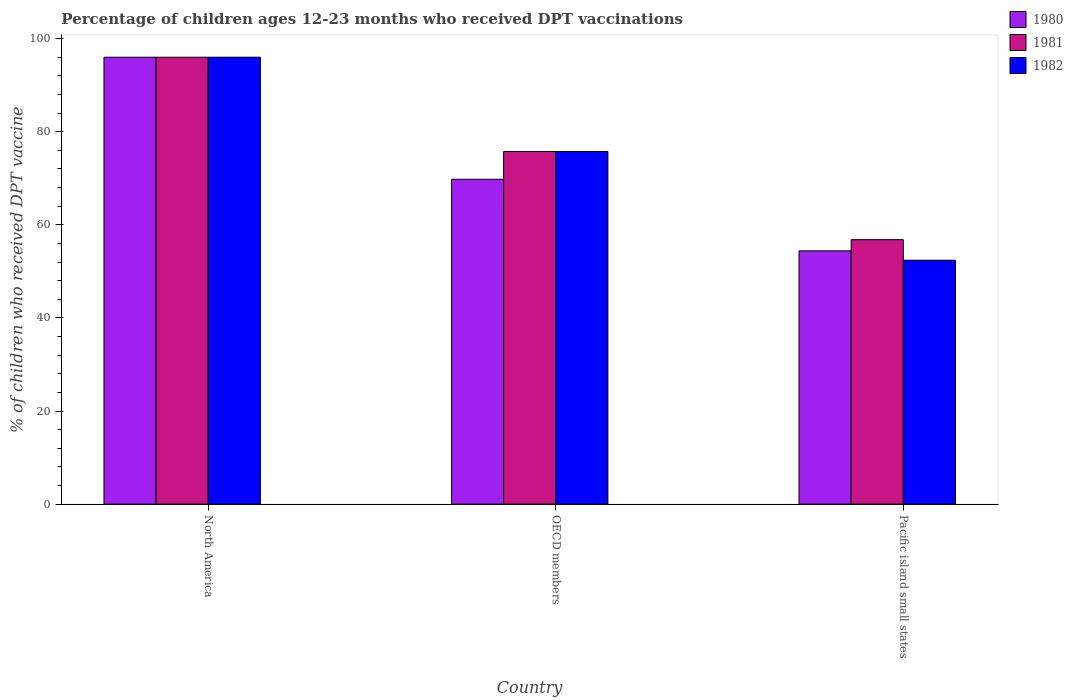How many groups of bars are there?
Offer a terse response. 3. Are the number of bars per tick equal to the number of legend labels?
Offer a very short reply. Yes. How many bars are there on the 1st tick from the left?
Provide a succinct answer. 3. How many bars are there on the 2nd tick from the right?
Ensure brevity in your answer.  3. What is the label of the 2nd group of bars from the left?
Give a very brief answer. OECD members. What is the percentage of children who received DPT vaccination in 1980 in OECD members?
Your response must be concise. 69.79. Across all countries, what is the maximum percentage of children who received DPT vaccination in 1980?
Your answer should be compact. 96. Across all countries, what is the minimum percentage of children who received DPT vaccination in 1980?
Keep it short and to the point. 54.41. In which country was the percentage of children who received DPT vaccination in 1982 minimum?
Your answer should be very brief. Pacific island small states. What is the total percentage of children who received DPT vaccination in 1981 in the graph?
Offer a terse response. 228.56. What is the difference between the percentage of children who received DPT vaccination in 1981 in North America and that in OECD members?
Your response must be concise. 20.25. What is the difference between the percentage of children who received DPT vaccination in 1981 in North America and the percentage of children who received DPT vaccination in 1982 in OECD members?
Provide a short and direct response. 20.25. What is the average percentage of children who received DPT vaccination in 1981 per country?
Give a very brief answer. 76.19. What is the difference between the percentage of children who received DPT vaccination of/in 1980 and percentage of children who received DPT vaccination of/in 1982 in Pacific island small states?
Offer a terse response. 2.01. In how many countries, is the percentage of children who received DPT vaccination in 1982 greater than 72 %?
Offer a terse response. 2. What is the ratio of the percentage of children who received DPT vaccination in 1982 in OECD members to that in Pacific island small states?
Ensure brevity in your answer.  1.45. What is the difference between the highest and the second highest percentage of children who received DPT vaccination in 1980?
Your answer should be very brief. 26.21. What is the difference between the highest and the lowest percentage of children who received DPT vaccination in 1982?
Your answer should be very brief. 43.6. What does the 1st bar from the right in Pacific island small states represents?
Your response must be concise. 1982. Are all the bars in the graph horizontal?
Make the answer very short. No. How many countries are there in the graph?
Provide a short and direct response. 3. What is the difference between two consecutive major ticks on the Y-axis?
Offer a terse response. 20. Are the values on the major ticks of Y-axis written in scientific E-notation?
Offer a terse response. No. Does the graph contain any zero values?
Provide a succinct answer. No. How many legend labels are there?
Provide a succinct answer. 3. How are the legend labels stacked?
Give a very brief answer. Vertical. What is the title of the graph?
Make the answer very short. Percentage of children ages 12-23 months who received DPT vaccinations. What is the label or title of the Y-axis?
Offer a very short reply. % of children who received DPT vaccine. What is the % of children who received DPT vaccine of 1980 in North America?
Keep it short and to the point. 96. What is the % of children who received DPT vaccine in 1981 in North America?
Make the answer very short. 96. What is the % of children who received DPT vaccine in 1982 in North America?
Ensure brevity in your answer.  96. What is the % of children who received DPT vaccine of 1980 in OECD members?
Offer a very short reply. 69.79. What is the % of children who received DPT vaccine of 1981 in OECD members?
Make the answer very short. 75.75. What is the % of children who received DPT vaccine in 1982 in OECD members?
Provide a succinct answer. 75.75. What is the % of children who received DPT vaccine of 1980 in Pacific island small states?
Offer a terse response. 54.41. What is the % of children who received DPT vaccine of 1981 in Pacific island small states?
Provide a succinct answer. 56.81. What is the % of children who received DPT vaccine in 1982 in Pacific island small states?
Provide a succinct answer. 52.4. Across all countries, what is the maximum % of children who received DPT vaccine of 1980?
Make the answer very short. 96. Across all countries, what is the maximum % of children who received DPT vaccine in 1981?
Provide a succinct answer. 96. Across all countries, what is the maximum % of children who received DPT vaccine in 1982?
Your answer should be very brief. 96. Across all countries, what is the minimum % of children who received DPT vaccine in 1980?
Your response must be concise. 54.41. Across all countries, what is the minimum % of children who received DPT vaccine in 1981?
Offer a very short reply. 56.81. Across all countries, what is the minimum % of children who received DPT vaccine of 1982?
Give a very brief answer. 52.4. What is the total % of children who received DPT vaccine of 1980 in the graph?
Provide a succinct answer. 220.19. What is the total % of children who received DPT vaccine in 1981 in the graph?
Offer a very short reply. 228.56. What is the total % of children who received DPT vaccine of 1982 in the graph?
Ensure brevity in your answer.  224.15. What is the difference between the % of children who received DPT vaccine in 1980 in North America and that in OECD members?
Keep it short and to the point. 26.21. What is the difference between the % of children who received DPT vaccine in 1981 in North America and that in OECD members?
Your response must be concise. 20.25. What is the difference between the % of children who received DPT vaccine in 1982 in North America and that in OECD members?
Make the answer very short. 20.25. What is the difference between the % of children who received DPT vaccine of 1980 in North America and that in Pacific island small states?
Your answer should be compact. 41.59. What is the difference between the % of children who received DPT vaccine of 1981 in North America and that in Pacific island small states?
Your answer should be very brief. 39.19. What is the difference between the % of children who received DPT vaccine in 1982 in North America and that in Pacific island small states?
Your answer should be compact. 43.6. What is the difference between the % of children who received DPT vaccine of 1980 in OECD members and that in Pacific island small states?
Your answer should be compact. 15.38. What is the difference between the % of children who received DPT vaccine of 1981 in OECD members and that in Pacific island small states?
Make the answer very short. 18.93. What is the difference between the % of children who received DPT vaccine in 1982 in OECD members and that in Pacific island small states?
Provide a short and direct response. 23.35. What is the difference between the % of children who received DPT vaccine in 1980 in North America and the % of children who received DPT vaccine in 1981 in OECD members?
Offer a terse response. 20.25. What is the difference between the % of children who received DPT vaccine in 1980 in North America and the % of children who received DPT vaccine in 1982 in OECD members?
Provide a short and direct response. 20.25. What is the difference between the % of children who received DPT vaccine in 1981 in North America and the % of children who received DPT vaccine in 1982 in OECD members?
Keep it short and to the point. 20.25. What is the difference between the % of children who received DPT vaccine of 1980 in North America and the % of children who received DPT vaccine of 1981 in Pacific island small states?
Give a very brief answer. 39.19. What is the difference between the % of children who received DPT vaccine of 1980 in North America and the % of children who received DPT vaccine of 1982 in Pacific island small states?
Offer a terse response. 43.6. What is the difference between the % of children who received DPT vaccine of 1981 in North America and the % of children who received DPT vaccine of 1982 in Pacific island small states?
Your answer should be very brief. 43.6. What is the difference between the % of children who received DPT vaccine in 1980 in OECD members and the % of children who received DPT vaccine in 1981 in Pacific island small states?
Your answer should be compact. 12.97. What is the difference between the % of children who received DPT vaccine in 1980 in OECD members and the % of children who received DPT vaccine in 1982 in Pacific island small states?
Offer a terse response. 17.39. What is the difference between the % of children who received DPT vaccine of 1981 in OECD members and the % of children who received DPT vaccine of 1982 in Pacific island small states?
Offer a terse response. 23.35. What is the average % of children who received DPT vaccine in 1980 per country?
Make the answer very short. 73.4. What is the average % of children who received DPT vaccine of 1981 per country?
Ensure brevity in your answer.  76.19. What is the average % of children who received DPT vaccine of 1982 per country?
Keep it short and to the point. 74.72. What is the difference between the % of children who received DPT vaccine of 1980 and % of children who received DPT vaccine of 1981 in North America?
Your answer should be very brief. 0. What is the difference between the % of children who received DPT vaccine in 1980 and % of children who received DPT vaccine in 1981 in OECD members?
Make the answer very short. -5.96. What is the difference between the % of children who received DPT vaccine in 1980 and % of children who received DPT vaccine in 1982 in OECD members?
Provide a short and direct response. -5.96. What is the difference between the % of children who received DPT vaccine in 1981 and % of children who received DPT vaccine in 1982 in OECD members?
Your answer should be compact. -0. What is the difference between the % of children who received DPT vaccine of 1980 and % of children who received DPT vaccine of 1981 in Pacific island small states?
Give a very brief answer. -2.41. What is the difference between the % of children who received DPT vaccine in 1980 and % of children who received DPT vaccine in 1982 in Pacific island small states?
Your answer should be compact. 2.01. What is the difference between the % of children who received DPT vaccine in 1981 and % of children who received DPT vaccine in 1982 in Pacific island small states?
Ensure brevity in your answer.  4.42. What is the ratio of the % of children who received DPT vaccine in 1980 in North America to that in OECD members?
Offer a terse response. 1.38. What is the ratio of the % of children who received DPT vaccine in 1981 in North America to that in OECD members?
Give a very brief answer. 1.27. What is the ratio of the % of children who received DPT vaccine in 1982 in North America to that in OECD members?
Your answer should be compact. 1.27. What is the ratio of the % of children who received DPT vaccine in 1980 in North America to that in Pacific island small states?
Make the answer very short. 1.76. What is the ratio of the % of children who received DPT vaccine of 1981 in North America to that in Pacific island small states?
Offer a terse response. 1.69. What is the ratio of the % of children who received DPT vaccine in 1982 in North America to that in Pacific island small states?
Your answer should be compact. 1.83. What is the ratio of the % of children who received DPT vaccine of 1980 in OECD members to that in Pacific island small states?
Keep it short and to the point. 1.28. What is the ratio of the % of children who received DPT vaccine in 1982 in OECD members to that in Pacific island small states?
Ensure brevity in your answer.  1.45. What is the difference between the highest and the second highest % of children who received DPT vaccine of 1980?
Your response must be concise. 26.21. What is the difference between the highest and the second highest % of children who received DPT vaccine of 1981?
Offer a very short reply. 20.25. What is the difference between the highest and the second highest % of children who received DPT vaccine in 1982?
Ensure brevity in your answer.  20.25. What is the difference between the highest and the lowest % of children who received DPT vaccine in 1980?
Ensure brevity in your answer.  41.59. What is the difference between the highest and the lowest % of children who received DPT vaccine of 1981?
Make the answer very short. 39.19. What is the difference between the highest and the lowest % of children who received DPT vaccine of 1982?
Offer a terse response. 43.6. 